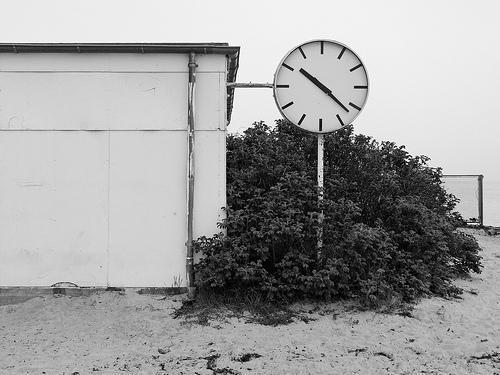How many clocks are there?
Give a very brief answer. 1. How many buildings are there to the left side of the clock?
Give a very brief answer. 1. 